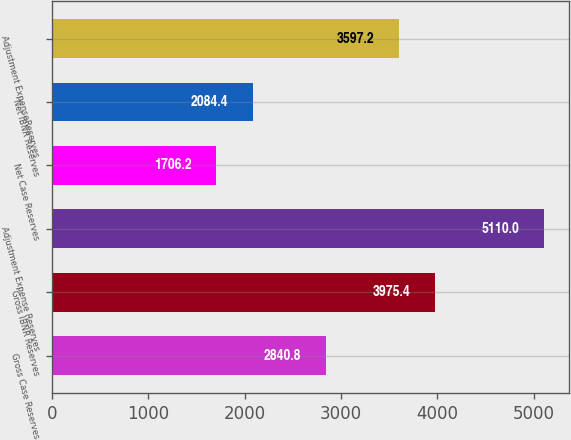Convert chart to OTSL. <chart><loc_0><loc_0><loc_500><loc_500><bar_chart><fcel>Gross Case Reserves<fcel>Gross IBNR Reserves<fcel>Adjustment Expense Reserves<fcel>Net Case Reserves<fcel>Net IBNR Reserves<fcel>Adjustment ExpenseReserves<nl><fcel>2840.8<fcel>3975.4<fcel>5110<fcel>1706.2<fcel>2084.4<fcel>3597.2<nl></chart> 